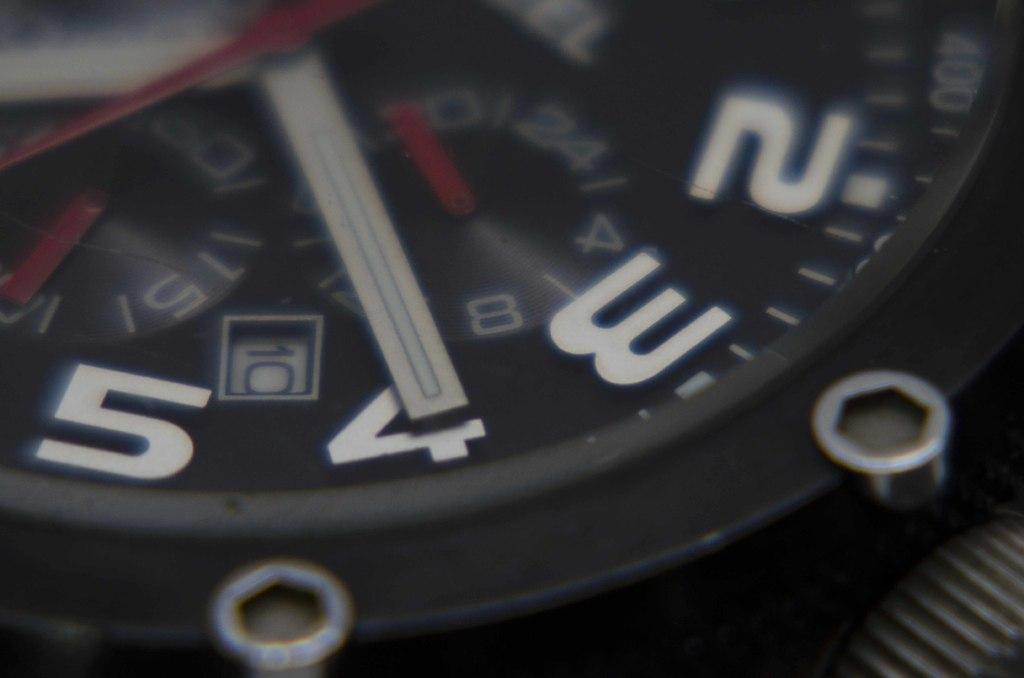<image>
Create a compact narrative representing the image presented. A clock face has the number 10 in a square lined in white. 